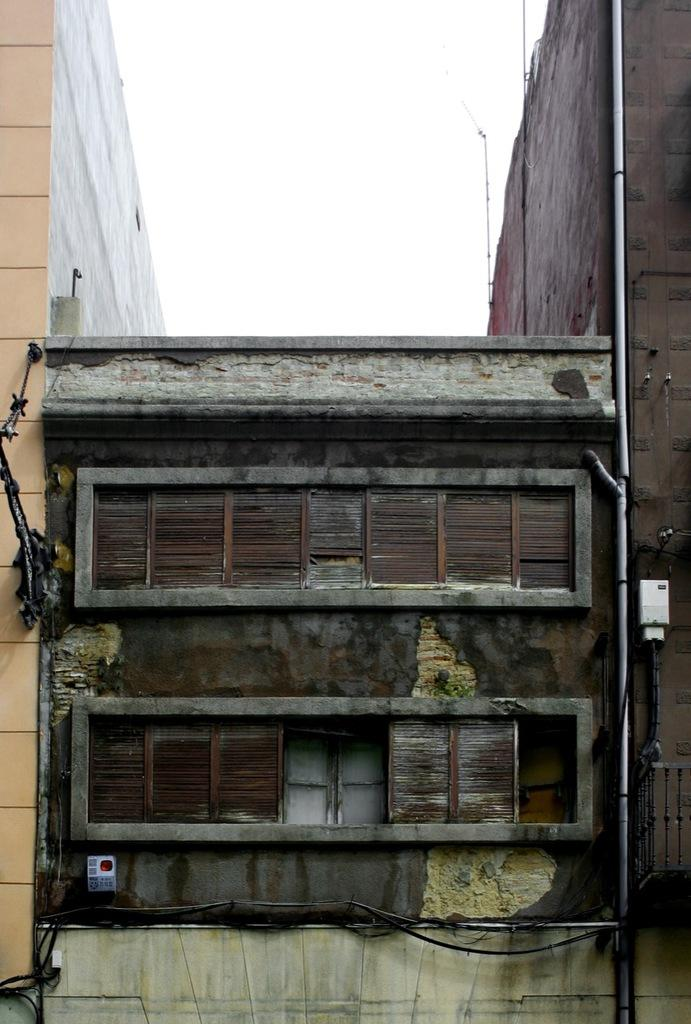What type of structures are present in the image? There are buildings in the image. What feature can be seen on the buildings? There are windows in the image. What other objects can be seen in the image? There are pipelines in the image. What is visible in the background of the image? The sky is visible in the image. Can you tell me how many oranges are on the windowsill in the image? There are no oranges present in the image. Is there a woman standing near the pipelines in the image? There is no woman present in the image. 